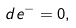<formula> <loc_0><loc_0><loc_500><loc_500>d e ^ { - } = 0 ,</formula> 